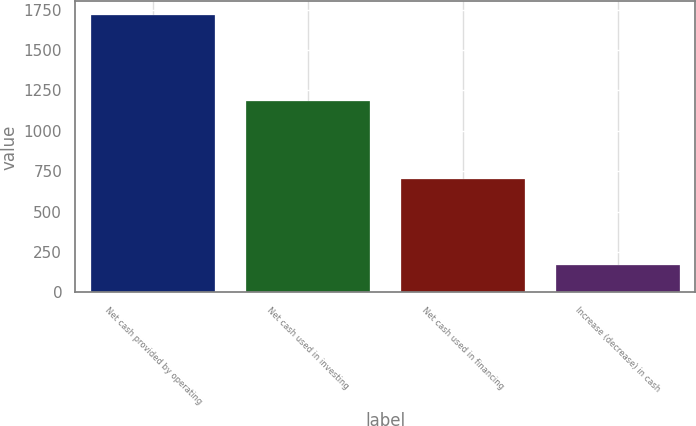Convert chart. <chart><loc_0><loc_0><loc_500><loc_500><bar_chart><fcel>Net cash provided by operating<fcel>Net cash used in investing<fcel>Net cash used in financing<fcel>Increase (decrease) in cash<nl><fcel>1716<fcel>1182<fcel>702<fcel>168<nl></chart> 